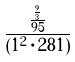<formula> <loc_0><loc_0><loc_500><loc_500>\frac { \frac { \frac { 9 } { 3 } } { 9 5 } } { ( 1 ^ { 2 } \cdot 2 8 1 ) }</formula> 